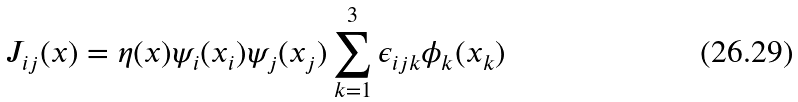Convert formula to latex. <formula><loc_0><loc_0><loc_500><loc_500>J _ { i j } ( x ) = \eta ( x ) \psi _ { i } ( x _ { i } ) \psi _ { j } ( x _ { j } ) \sum _ { k = 1 } ^ { 3 } \epsilon _ { i j k } \phi _ { k } ( x _ { k } )</formula> 